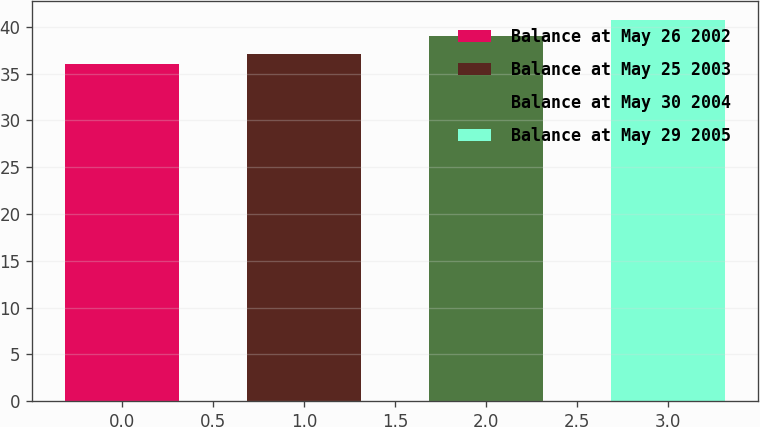Convert chart to OTSL. <chart><loc_0><loc_0><loc_500><loc_500><bar_chart><fcel>Balance at May 26 2002<fcel>Balance at May 25 2003<fcel>Balance at May 30 2004<fcel>Balance at May 29 2005<nl><fcel>36.03<fcel>37.07<fcel>38.97<fcel>40.68<nl></chart> 